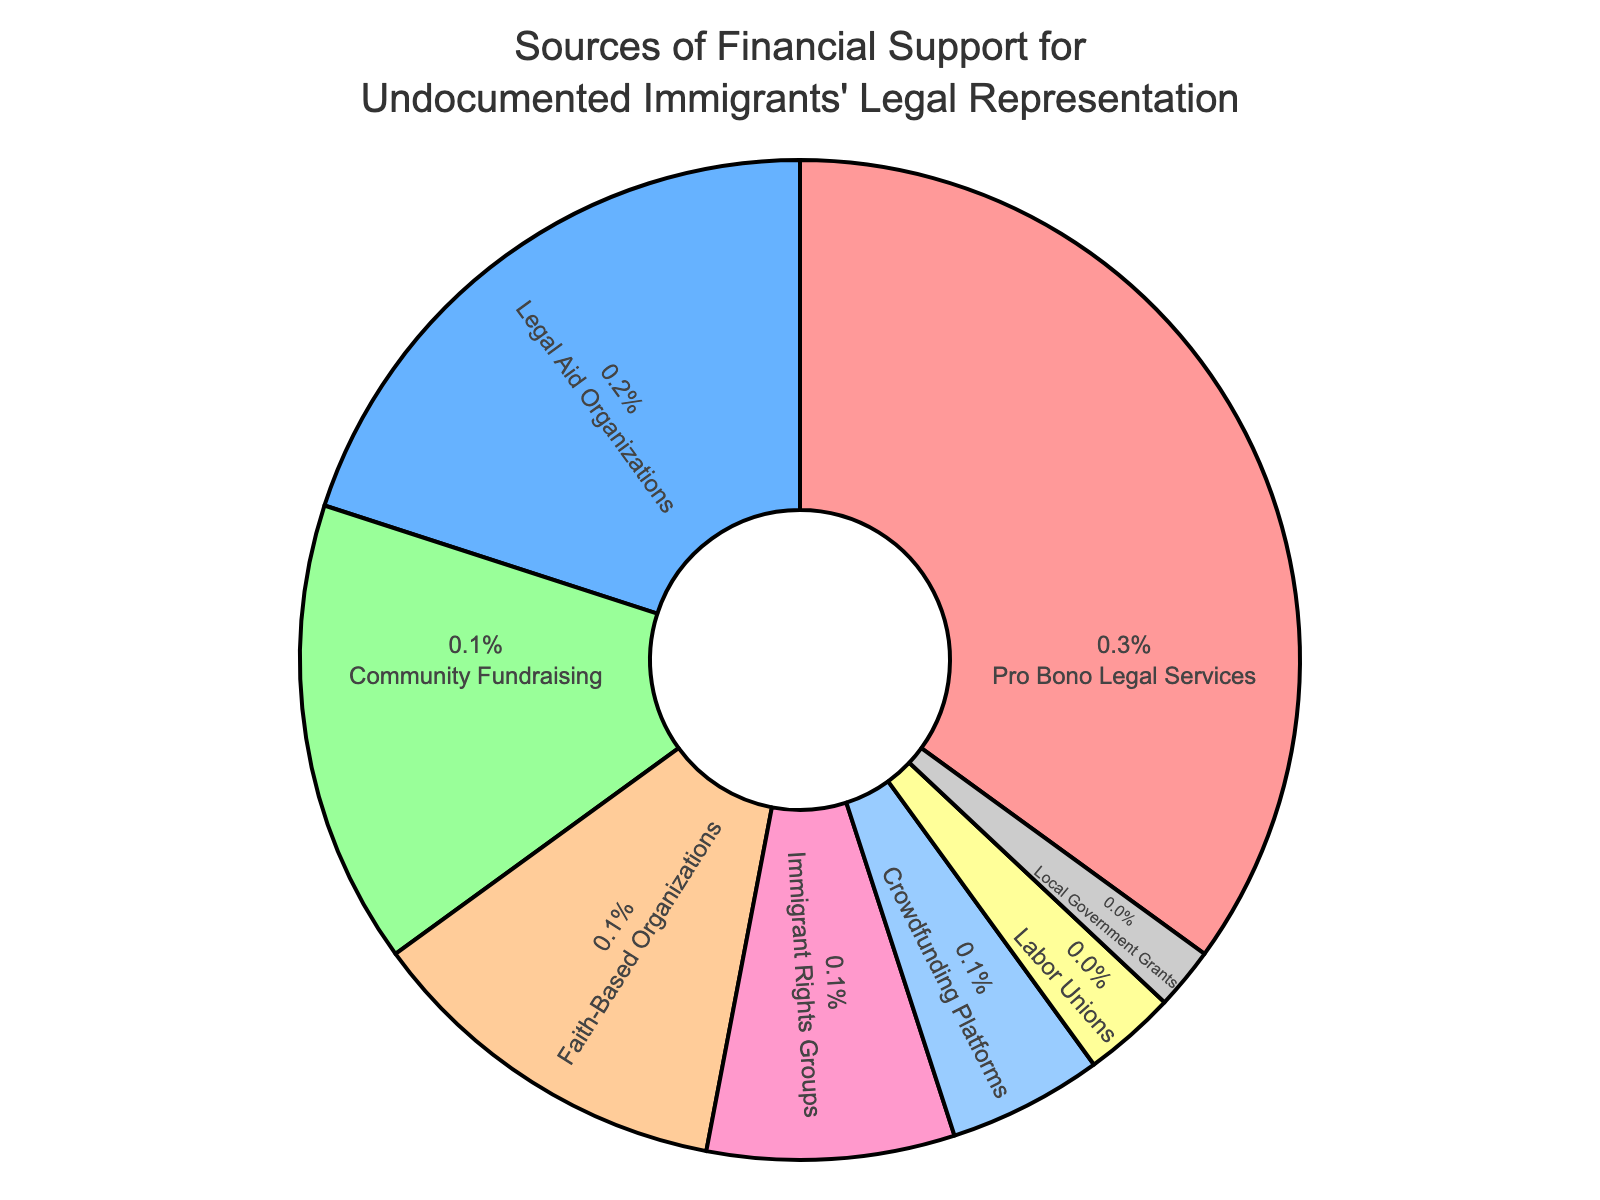Which source provides the largest percentage of financial support? The largest percentage slice on the pie chart is labeled "Pro Bono Legal Services," which occupies 35% of the chart.
Answer: Pro Bono Legal Services Which source contributes the least amount of financial support? The smallest slice of the pie chart is labeled "Local Government Grants," which occupies 2% of the chart.
Answer: Local Government Grants How much more does Pro Bono Legal Services contribute compared to Legal Aid Organizations? Subtract the percentage from Legal Aid Organizations (20%) from that of Pro Bono Legal Services (35%).
Answer: 15% What is the combined contribution of Community Fundraising, Faith-Based Organizations, and Immigrant Rights Groups? Add the percentages of Community Fundraising (15%), Faith-Based Organizations (12%), and Immigrant Rights Groups (8%). 15% + 12% + 8% = 35%.
Answer: 35% Which sources together cover more than half of the total financial support? Add the percentages of the largest sources until their total exceeds 50%. Pro Bono Legal Services (35%) + Legal Aid Organizations (20%) = 55%, which is just over half.
Answer: Pro Bono Legal Services and Legal Aid Organizations Is the percentage contribution of Crowdfunding Platforms greater than Labor Unions? Compare the slices for Crowdfunding Platforms (5%) and Labor Unions (3%). 5% > 3%.
Answer: Yes What is the total percentage of support from all other sources excluding Pro Bono Legal Services? Subtract the percentage of Pro Bono Legal Services (35%) from 100%. 100% - 35% = 65%.
Answer: 65% How does the percentage of Faith-Based Organizations compare to Community Fundraising? Compare the percentages: Faith-Based Organizations contribute 12%, while Community Fundraising contributes 15%. 12% < 15%.
Answer: Less What is the difference in percentage between Immigrant Rights Groups and Crowdfunding Platforms? Subtract the percentage of Crowdfunding Platforms (5%) from that of Immigrant Rights Groups (8%). 8% - 5% = 3%.
Answer: 3% If you combine the contributions of Labor Unions and Local Government Grants, what is their total percentage? Add the percentages of Labor Unions (3%) and Local Government Grants (2%). 3% + 2% = 5%.
Answer: 5% 